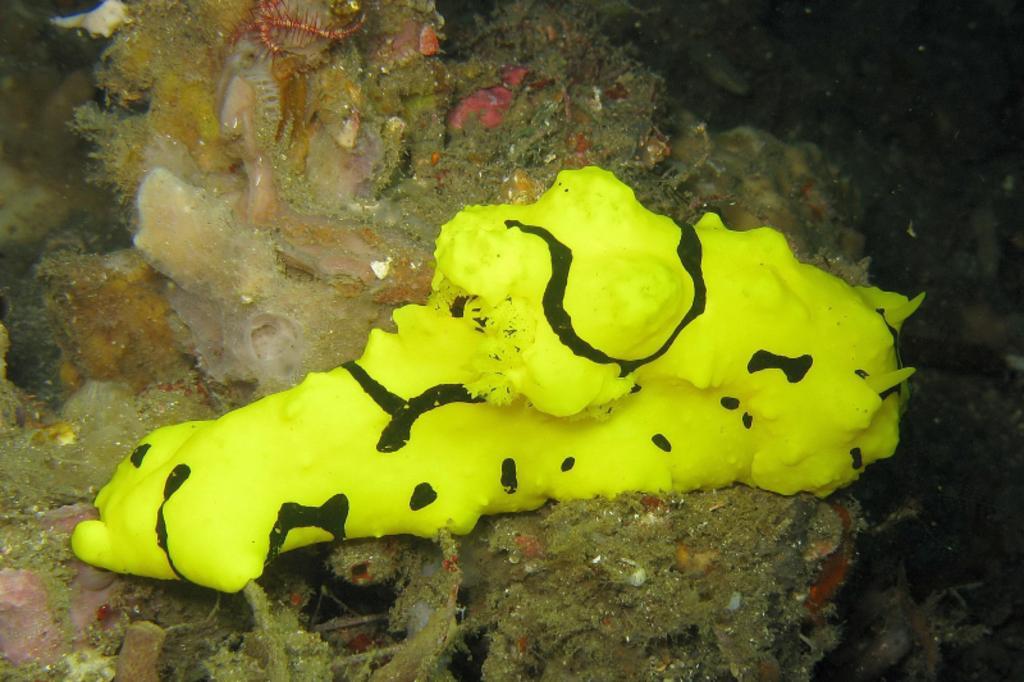Please provide a concise description of this image. In this image in the center there is an animal, and in the background there are some water plants and at the bottom also there are some water plants. 